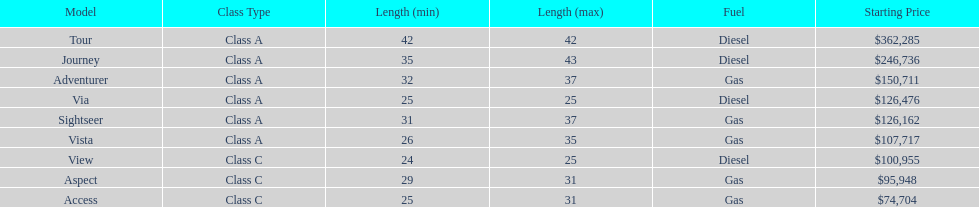Does the tour take diesel or gas? Diesel. 